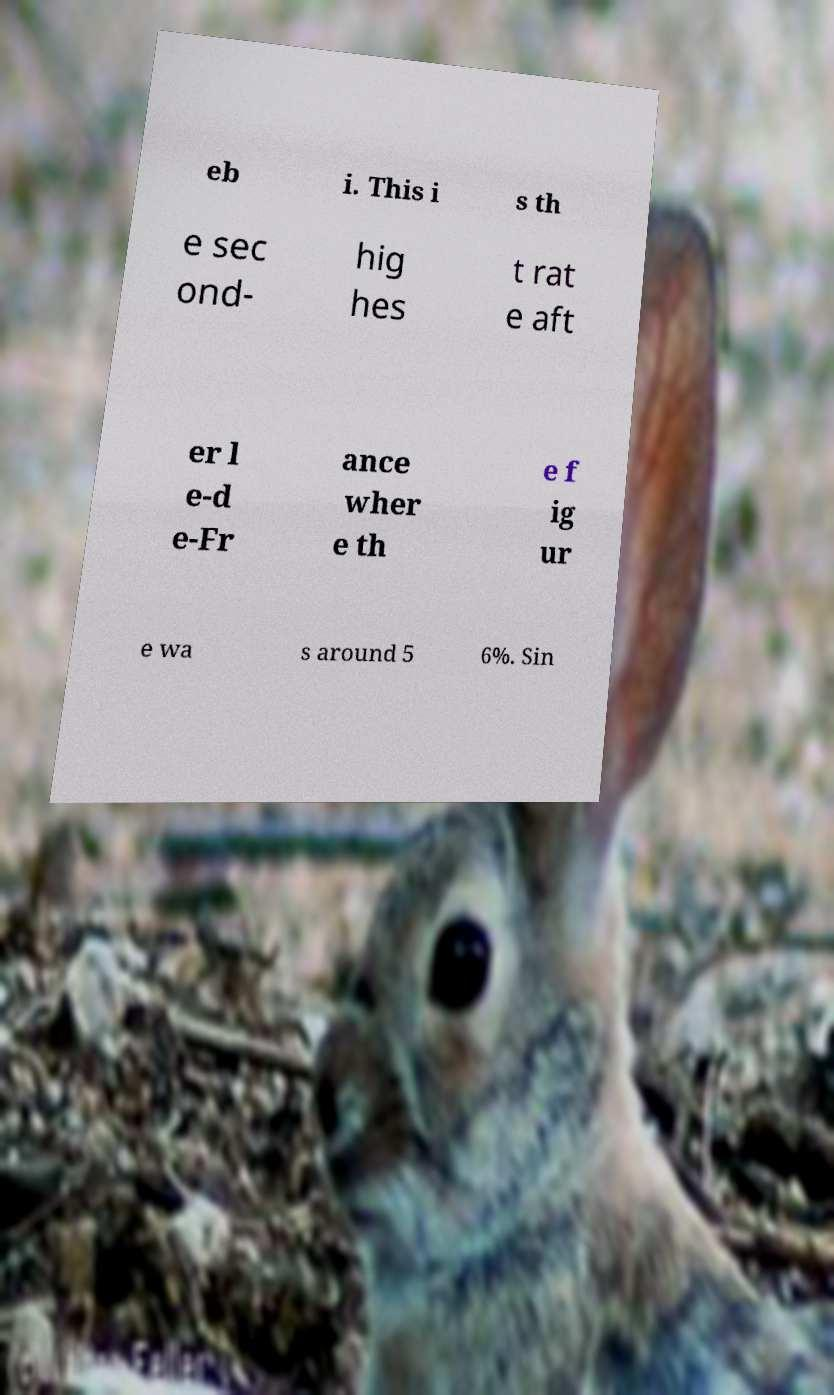Please identify and transcribe the text found in this image. eb i. This i s th e sec ond- hig hes t rat e aft er l e-d e-Fr ance wher e th e f ig ur e wa s around 5 6%. Sin 